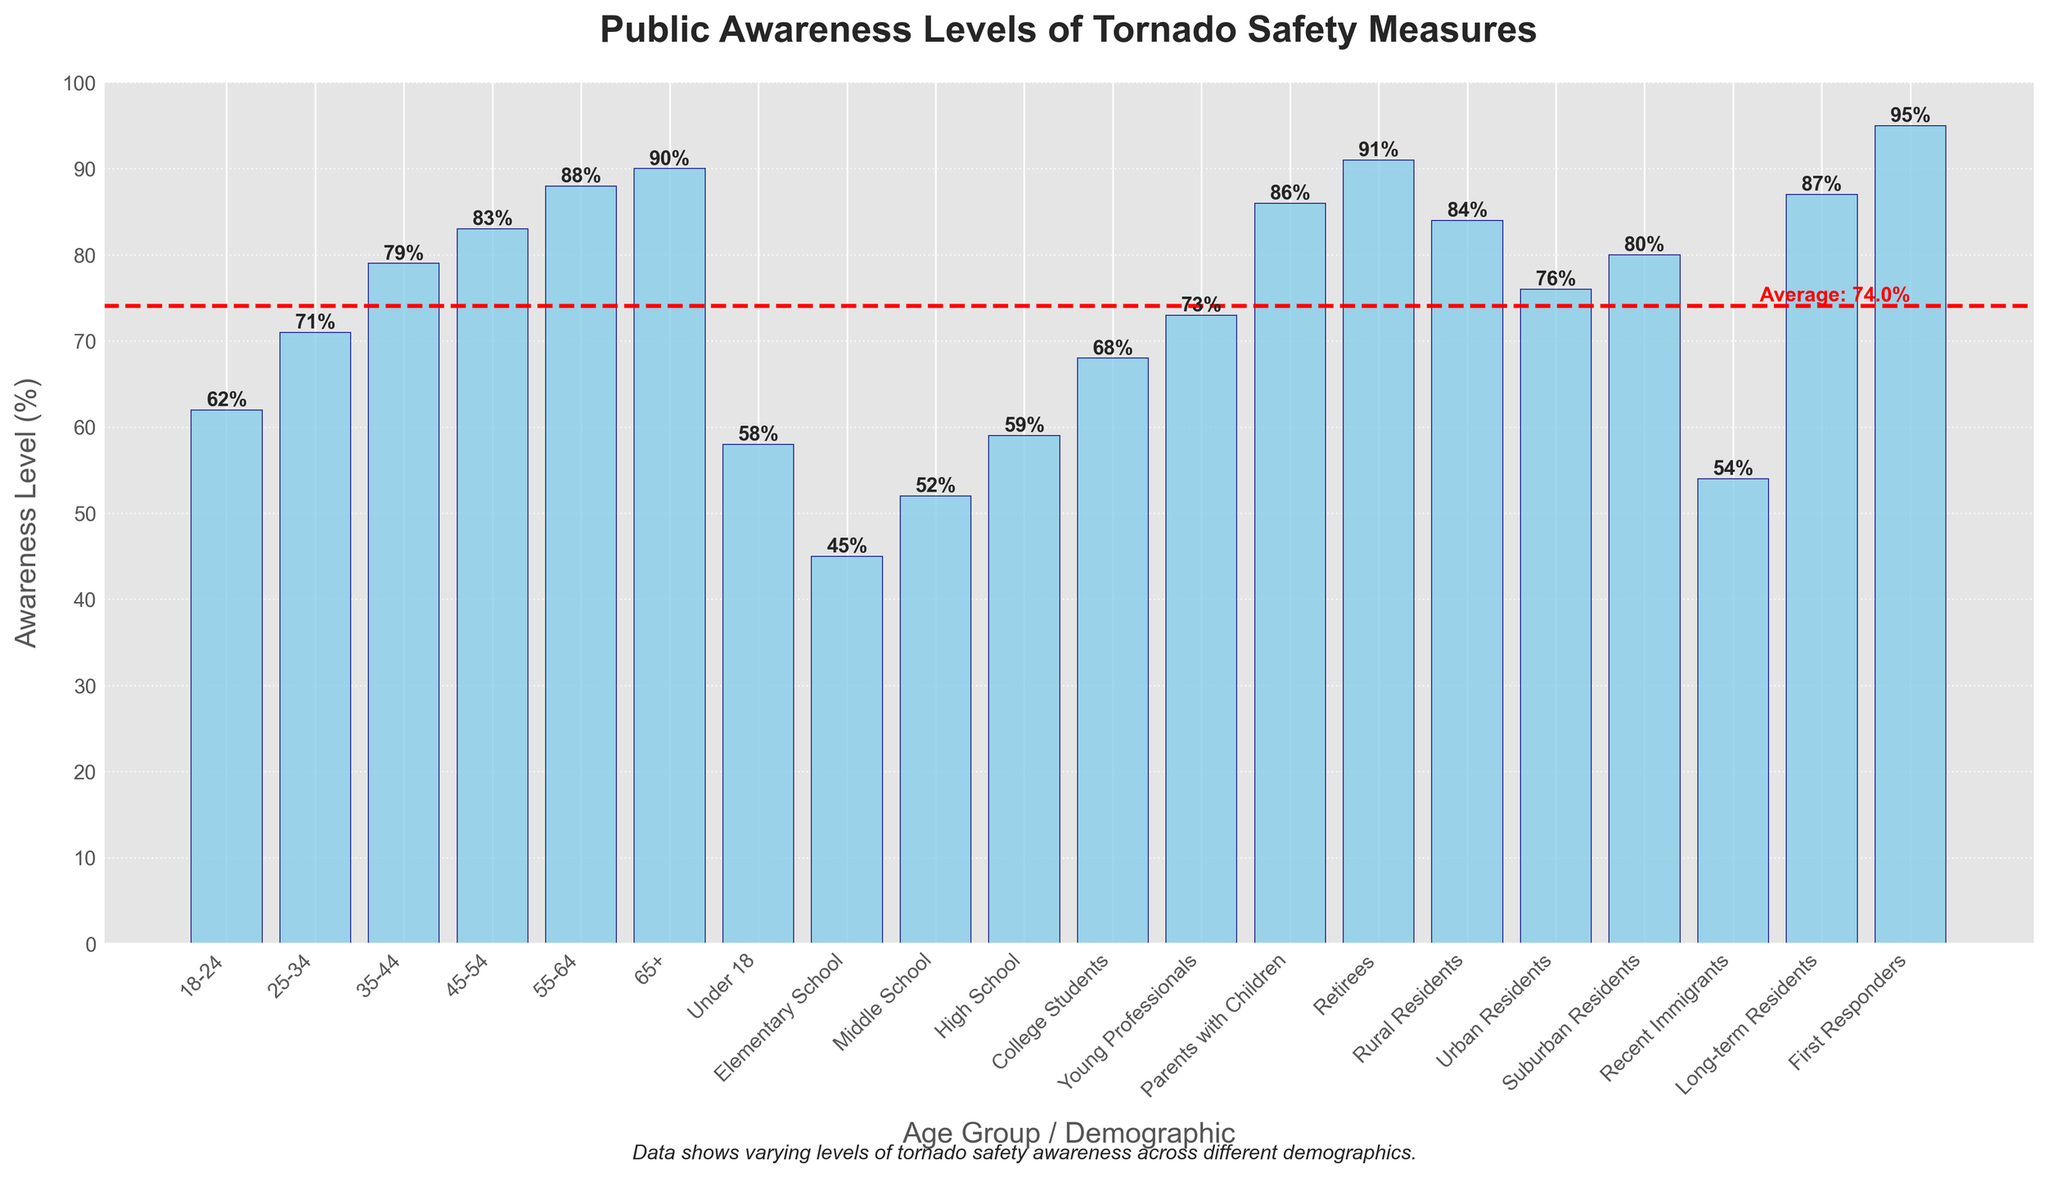Which age group shows the highest level of awareness? The age group of Retirees has the bar that reaches the highest level on the y-axis.
Answer: Retirees Which age group(s) has the lowest level of tornado safety awareness? Elementary School shows the lowest level of tornado safety awareness as its bar is the shortest on the y-axis.
Answer: Elementary School How does the awareness level of Urban Residents compare to Rural Residents? Urban Residents have a lower awareness level (76%) compared to Rural Residents (84%). This can be observed by noting that Rural Residents' bar is taller than Urban Residents'.
Answer: Urban Residents are lower What’s the average awareness level of the listed groups? To find the average, sum all awareness levels and then divide by the number of groups: (62+71+79+83+88+90+58+45+52+59+68+73+86+91+84+76+80+54+87+95)/20 = 75.4%.
Answer: 75.4% How do the awareness levels of Parents with Children and College Students differ? Parents with Children show an awareness level of 86% while College Students show an awareness level of 68%, indicating Parents with Children have a higher awareness by 18%.
Answer: Parents with Children are higher What is the median awareness level across all groups? To find the median, list all the awareness levels in ascending order and find the middle value. With 20 groups, the median will be the average of the 10th and 11th values: (68 + 71) / 2 = 69.5%.
Answer: 69.5% Which demographic exceeds the average awareness level indicated by the red horizontal line? The demographics such as Retirees (91%), Rural Residents (84%), Suburban Residents (80%), etc., have bars above the red horizontal line denoting the average awareness of 75.4%.
Answer: Retirees, Rural Residents, Suburban Residents, etc Is the awareness level of Recent Immigrants above or below 60%? The Recent Immigrants bar reaches 54% on the y-axis, indicating it is below 60%.
Answer: Below 60% By how much does the awareness level of First Responders exceed that of High School students? First Responders have an awareness level of 95%, and High School students have 59%. The difference is 95% - 59% = 36%.
Answer: 36% Which group falls just below the average awareness level? Long-term Residents have an awareness level of 87%, while Suburban Residents have 80%, so Suburban Residents fall just below the average level at the red line.
Answer: Suburban Residents 